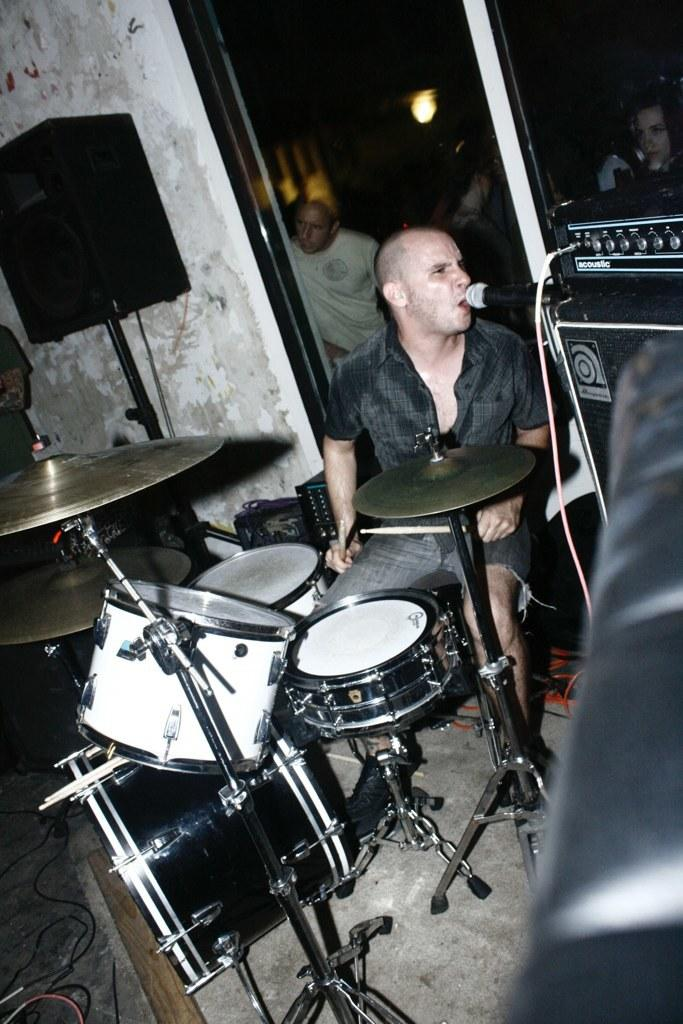What is the man in the image doing? The man is seated, singing, and playing drums. How is the man amplifying his voice in the image? The man is using a microphone. Can you describe the people in the background of the image? There are people visible in the background of the image. What type of sign can be seen in the image? There is no sign present in the image. How does the man wish for good luck in the image? The image does not depict the man wishing for good luck; he is singing and playing drums. 